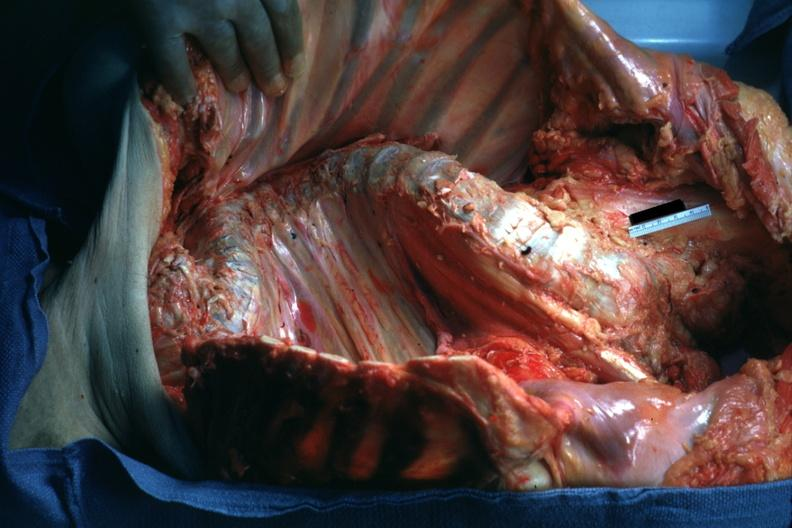what is present?
Answer the question using a single word or phrase. Joints 